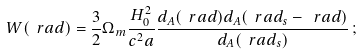<formula> <loc_0><loc_0><loc_500><loc_500>W ( \ r a d ) = \frac { 3 } { 2 } \Omega _ { m } \frac { H _ { 0 } ^ { 2 } } { c ^ { 2 } a } \frac { d _ { A } ( \ r a d ) d _ { A } ( \ r a d _ { s } - \ r a d ) } { d _ { A } ( \ r a d _ { s } ) } \, ;</formula> 